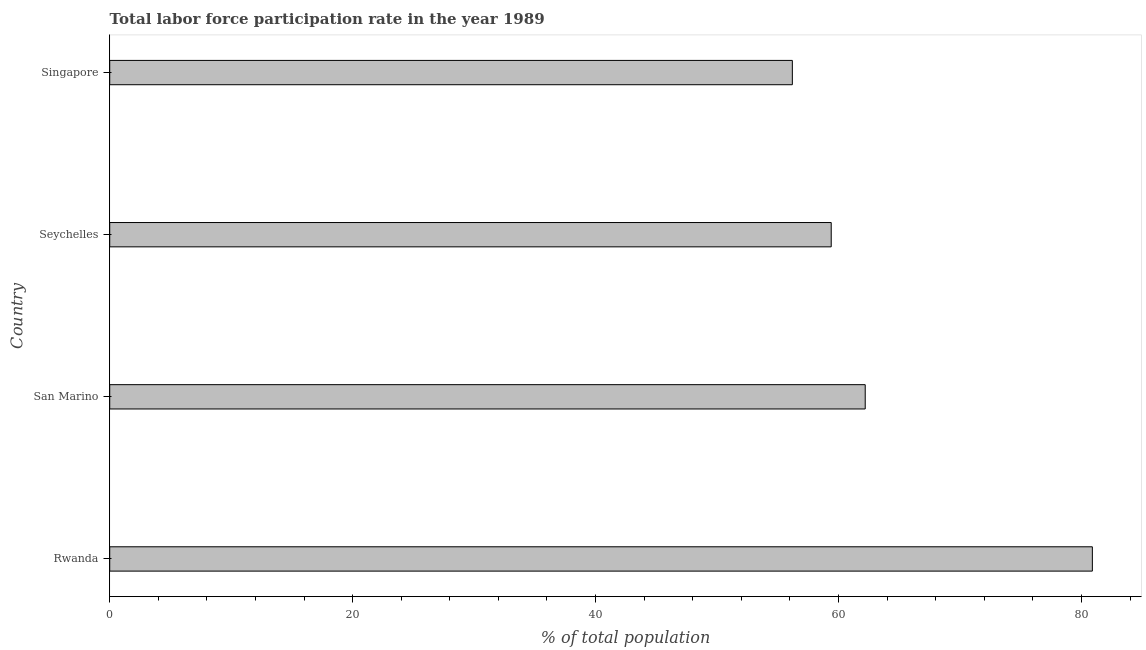What is the title of the graph?
Offer a very short reply. Total labor force participation rate in the year 1989. What is the label or title of the X-axis?
Provide a short and direct response. % of total population. What is the total labor force participation rate in San Marino?
Provide a succinct answer. 62.2. Across all countries, what is the maximum total labor force participation rate?
Your answer should be very brief. 80.9. Across all countries, what is the minimum total labor force participation rate?
Provide a succinct answer. 56.2. In which country was the total labor force participation rate maximum?
Your answer should be compact. Rwanda. In which country was the total labor force participation rate minimum?
Offer a terse response. Singapore. What is the sum of the total labor force participation rate?
Provide a short and direct response. 258.7. What is the average total labor force participation rate per country?
Keep it short and to the point. 64.67. What is the median total labor force participation rate?
Your answer should be compact. 60.8. What is the ratio of the total labor force participation rate in San Marino to that in Seychelles?
Provide a succinct answer. 1.05. Is the difference between the total labor force participation rate in Rwanda and Singapore greater than the difference between any two countries?
Make the answer very short. Yes. What is the difference between the highest and the second highest total labor force participation rate?
Make the answer very short. 18.7. What is the difference between the highest and the lowest total labor force participation rate?
Your answer should be very brief. 24.7. How many bars are there?
Give a very brief answer. 4. How many countries are there in the graph?
Give a very brief answer. 4. What is the % of total population of Rwanda?
Your answer should be very brief. 80.9. What is the % of total population in San Marino?
Provide a short and direct response. 62.2. What is the % of total population in Seychelles?
Ensure brevity in your answer.  59.4. What is the % of total population of Singapore?
Provide a short and direct response. 56.2. What is the difference between the % of total population in Rwanda and Seychelles?
Ensure brevity in your answer.  21.5. What is the difference between the % of total population in Rwanda and Singapore?
Your response must be concise. 24.7. What is the difference between the % of total population in San Marino and Seychelles?
Your answer should be compact. 2.8. What is the difference between the % of total population in San Marino and Singapore?
Make the answer very short. 6. What is the ratio of the % of total population in Rwanda to that in San Marino?
Give a very brief answer. 1.3. What is the ratio of the % of total population in Rwanda to that in Seychelles?
Provide a short and direct response. 1.36. What is the ratio of the % of total population in Rwanda to that in Singapore?
Your answer should be compact. 1.44. What is the ratio of the % of total population in San Marino to that in Seychelles?
Offer a very short reply. 1.05. What is the ratio of the % of total population in San Marino to that in Singapore?
Give a very brief answer. 1.11. What is the ratio of the % of total population in Seychelles to that in Singapore?
Offer a terse response. 1.06. 